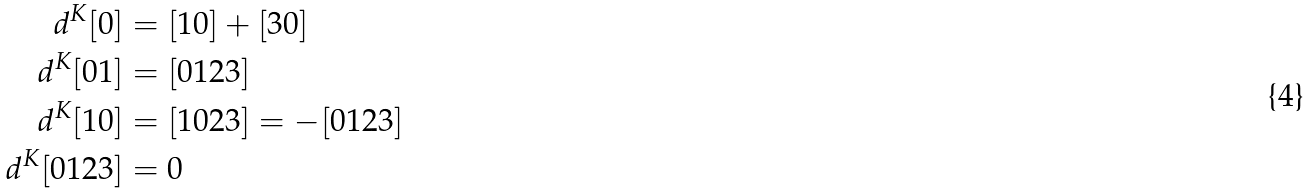<formula> <loc_0><loc_0><loc_500><loc_500>d ^ { K } [ 0 ] & = [ 1 0 ] + [ 3 0 ] \\ d ^ { K } [ 0 1 ] & = [ 0 1 2 3 ] \\ d ^ { K } [ 1 0 ] & = [ 1 0 2 3 ] = - [ 0 1 2 3 ] \\ d ^ { K } [ 0 1 2 3 ] & = 0</formula> 